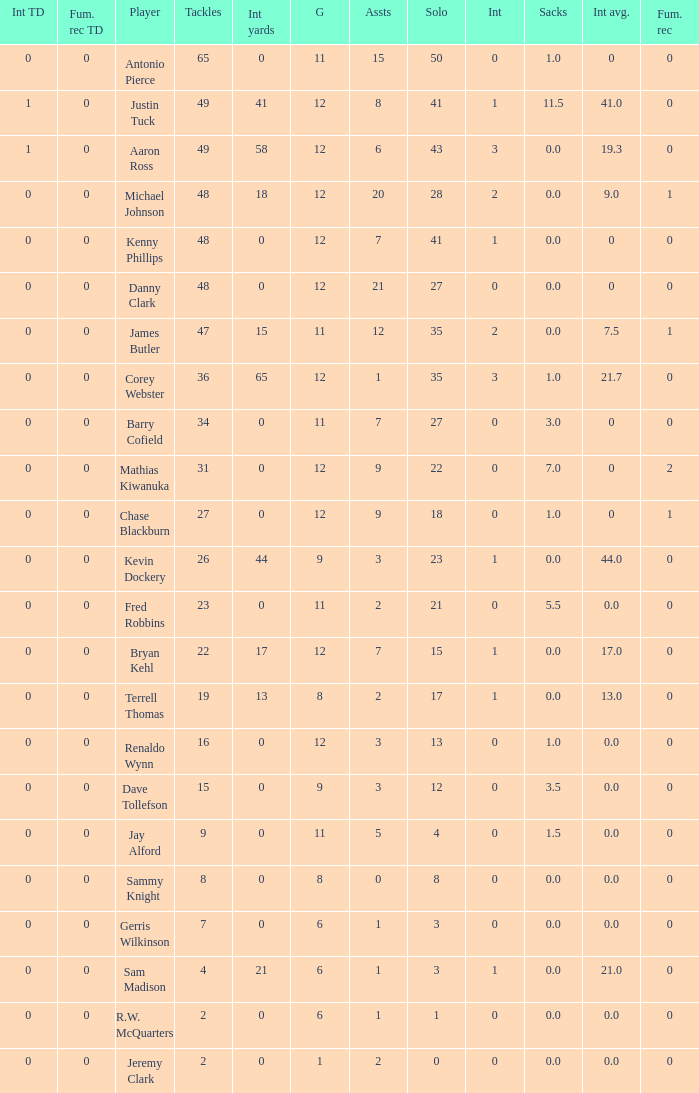Name the least amount of int yards 0.0. 